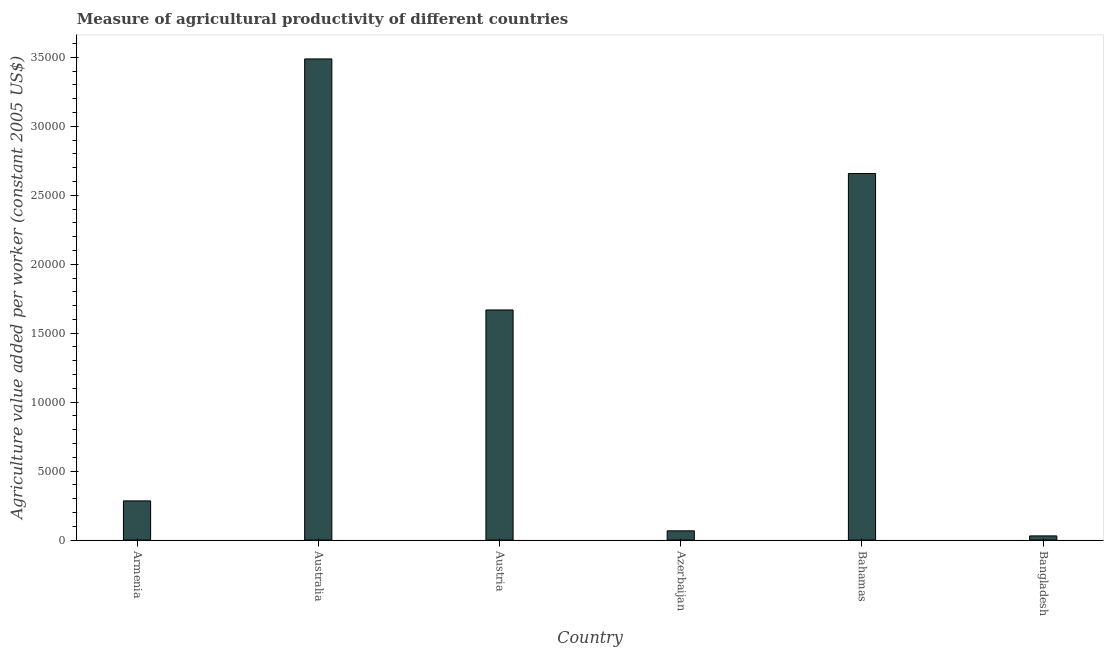Does the graph contain any zero values?
Make the answer very short. No. Does the graph contain grids?
Your response must be concise. No. What is the title of the graph?
Provide a succinct answer. Measure of agricultural productivity of different countries. What is the label or title of the Y-axis?
Ensure brevity in your answer.  Agriculture value added per worker (constant 2005 US$). What is the agriculture value added per worker in Bahamas?
Offer a very short reply. 2.66e+04. Across all countries, what is the maximum agriculture value added per worker?
Provide a short and direct response. 3.49e+04. Across all countries, what is the minimum agriculture value added per worker?
Offer a terse response. 304.62. In which country was the agriculture value added per worker maximum?
Provide a short and direct response. Australia. In which country was the agriculture value added per worker minimum?
Make the answer very short. Bangladesh. What is the sum of the agriculture value added per worker?
Provide a succinct answer. 8.20e+04. What is the difference between the agriculture value added per worker in Bahamas and Bangladesh?
Keep it short and to the point. 2.63e+04. What is the average agriculture value added per worker per country?
Provide a succinct answer. 1.37e+04. What is the median agriculture value added per worker?
Make the answer very short. 9763.39. What is the ratio of the agriculture value added per worker in Australia to that in Bahamas?
Your answer should be very brief. 1.31. Is the difference between the agriculture value added per worker in Austria and Azerbaijan greater than the difference between any two countries?
Provide a succinct answer. No. What is the difference between the highest and the second highest agriculture value added per worker?
Make the answer very short. 8309.79. What is the difference between the highest and the lowest agriculture value added per worker?
Your response must be concise. 3.46e+04. Are all the bars in the graph horizontal?
Give a very brief answer. No. What is the Agriculture value added per worker (constant 2005 US$) in Armenia?
Give a very brief answer. 2842.7. What is the Agriculture value added per worker (constant 2005 US$) in Australia?
Your response must be concise. 3.49e+04. What is the Agriculture value added per worker (constant 2005 US$) in Austria?
Offer a terse response. 1.67e+04. What is the Agriculture value added per worker (constant 2005 US$) of Azerbaijan?
Keep it short and to the point. 671.12. What is the Agriculture value added per worker (constant 2005 US$) of Bahamas?
Your response must be concise. 2.66e+04. What is the Agriculture value added per worker (constant 2005 US$) in Bangladesh?
Your answer should be very brief. 304.62. What is the difference between the Agriculture value added per worker (constant 2005 US$) in Armenia and Australia?
Make the answer very short. -3.20e+04. What is the difference between the Agriculture value added per worker (constant 2005 US$) in Armenia and Austria?
Your answer should be compact. -1.38e+04. What is the difference between the Agriculture value added per worker (constant 2005 US$) in Armenia and Azerbaijan?
Give a very brief answer. 2171.58. What is the difference between the Agriculture value added per worker (constant 2005 US$) in Armenia and Bahamas?
Provide a succinct answer. -2.37e+04. What is the difference between the Agriculture value added per worker (constant 2005 US$) in Armenia and Bangladesh?
Offer a very short reply. 2538.08. What is the difference between the Agriculture value added per worker (constant 2005 US$) in Australia and Austria?
Your answer should be very brief. 1.82e+04. What is the difference between the Agriculture value added per worker (constant 2005 US$) in Australia and Azerbaijan?
Your answer should be very brief. 3.42e+04. What is the difference between the Agriculture value added per worker (constant 2005 US$) in Australia and Bahamas?
Provide a short and direct response. 8309.79. What is the difference between the Agriculture value added per worker (constant 2005 US$) in Australia and Bangladesh?
Offer a very short reply. 3.46e+04. What is the difference between the Agriculture value added per worker (constant 2005 US$) in Austria and Azerbaijan?
Offer a terse response. 1.60e+04. What is the difference between the Agriculture value added per worker (constant 2005 US$) in Austria and Bahamas?
Give a very brief answer. -9888.08. What is the difference between the Agriculture value added per worker (constant 2005 US$) in Austria and Bangladesh?
Give a very brief answer. 1.64e+04. What is the difference between the Agriculture value added per worker (constant 2005 US$) in Azerbaijan and Bahamas?
Keep it short and to the point. -2.59e+04. What is the difference between the Agriculture value added per worker (constant 2005 US$) in Azerbaijan and Bangladesh?
Make the answer very short. 366.5. What is the difference between the Agriculture value added per worker (constant 2005 US$) in Bahamas and Bangladesh?
Make the answer very short. 2.63e+04. What is the ratio of the Agriculture value added per worker (constant 2005 US$) in Armenia to that in Australia?
Provide a short and direct response. 0.08. What is the ratio of the Agriculture value added per worker (constant 2005 US$) in Armenia to that in Austria?
Ensure brevity in your answer.  0.17. What is the ratio of the Agriculture value added per worker (constant 2005 US$) in Armenia to that in Azerbaijan?
Keep it short and to the point. 4.24. What is the ratio of the Agriculture value added per worker (constant 2005 US$) in Armenia to that in Bahamas?
Your answer should be very brief. 0.11. What is the ratio of the Agriculture value added per worker (constant 2005 US$) in Armenia to that in Bangladesh?
Your answer should be compact. 9.33. What is the ratio of the Agriculture value added per worker (constant 2005 US$) in Australia to that in Austria?
Provide a short and direct response. 2.09. What is the ratio of the Agriculture value added per worker (constant 2005 US$) in Australia to that in Azerbaijan?
Keep it short and to the point. 51.98. What is the ratio of the Agriculture value added per worker (constant 2005 US$) in Australia to that in Bahamas?
Provide a succinct answer. 1.31. What is the ratio of the Agriculture value added per worker (constant 2005 US$) in Australia to that in Bangladesh?
Offer a very short reply. 114.51. What is the ratio of the Agriculture value added per worker (constant 2005 US$) in Austria to that in Azerbaijan?
Provide a short and direct response. 24.86. What is the ratio of the Agriculture value added per worker (constant 2005 US$) in Austria to that in Bahamas?
Keep it short and to the point. 0.63. What is the ratio of the Agriculture value added per worker (constant 2005 US$) in Austria to that in Bangladesh?
Make the answer very short. 54.77. What is the ratio of the Agriculture value added per worker (constant 2005 US$) in Azerbaijan to that in Bahamas?
Your response must be concise. 0.03. What is the ratio of the Agriculture value added per worker (constant 2005 US$) in Azerbaijan to that in Bangladesh?
Your answer should be very brief. 2.2. What is the ratio of the Agriculture value added per worker (constant 2005 US$) in Bahamas to that in Bangladesh?
Offer a very short reply. 87.23. 